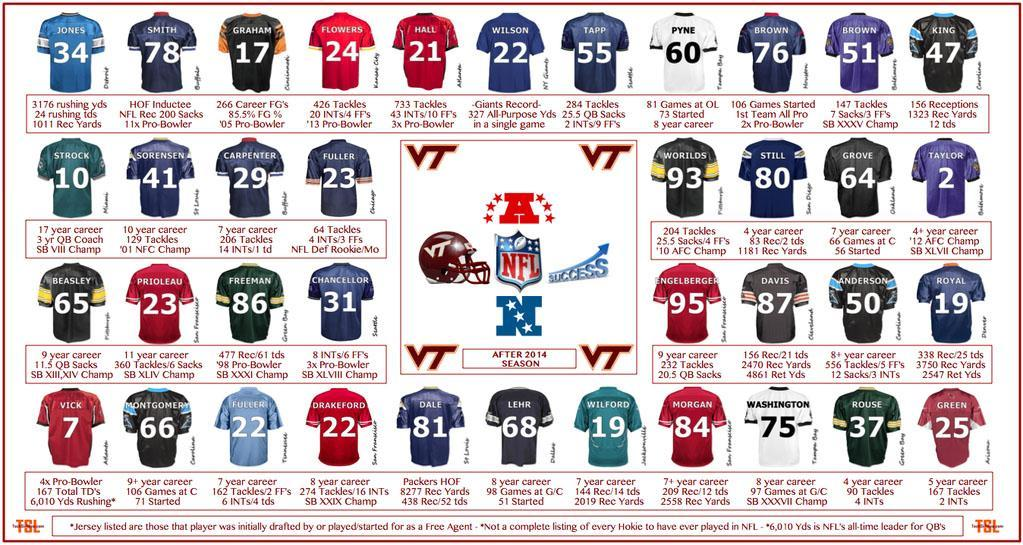What is the name of the third person in the third row?
Answer the question with a short phrase. Freeman What is the Jersey number of Tapp? 55 What is the Jersey number of Royal? 19 What is the Jersey number of Dale? 81 How many Red Jerseys are there in the first row? 2 What is the year of experience of Anderson? 8+ year What is the color of Jersey Of Washington- red, yellow, green, white? White What is the no of tackles played by Rouse? 90 How many Green Jerseys are there in the fourth row? 1 What is the no of tackles played by Worilds? 93 tackles 